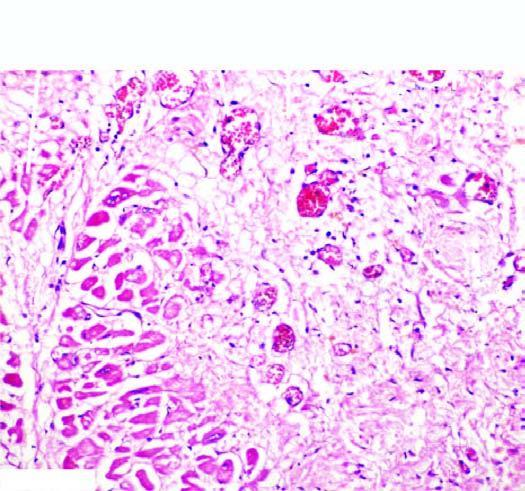does the infarcted area show ingrowth of inflammatory granulation tissue?
Answer the question using a single word or phrase. Yes 